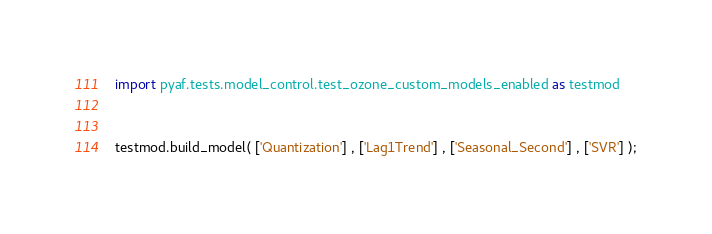Convert code to text. <code><loc_0><loc_0><loc_500><loc_500><_Python_>import pyaf.tests.model_control.test_ozone_custom_models_enabled as testmod


testmod.build_model( ['Quantization'] , ['Lag1Trend'] , ['Seasonal_Second'] , ['SVR'] );</code> 